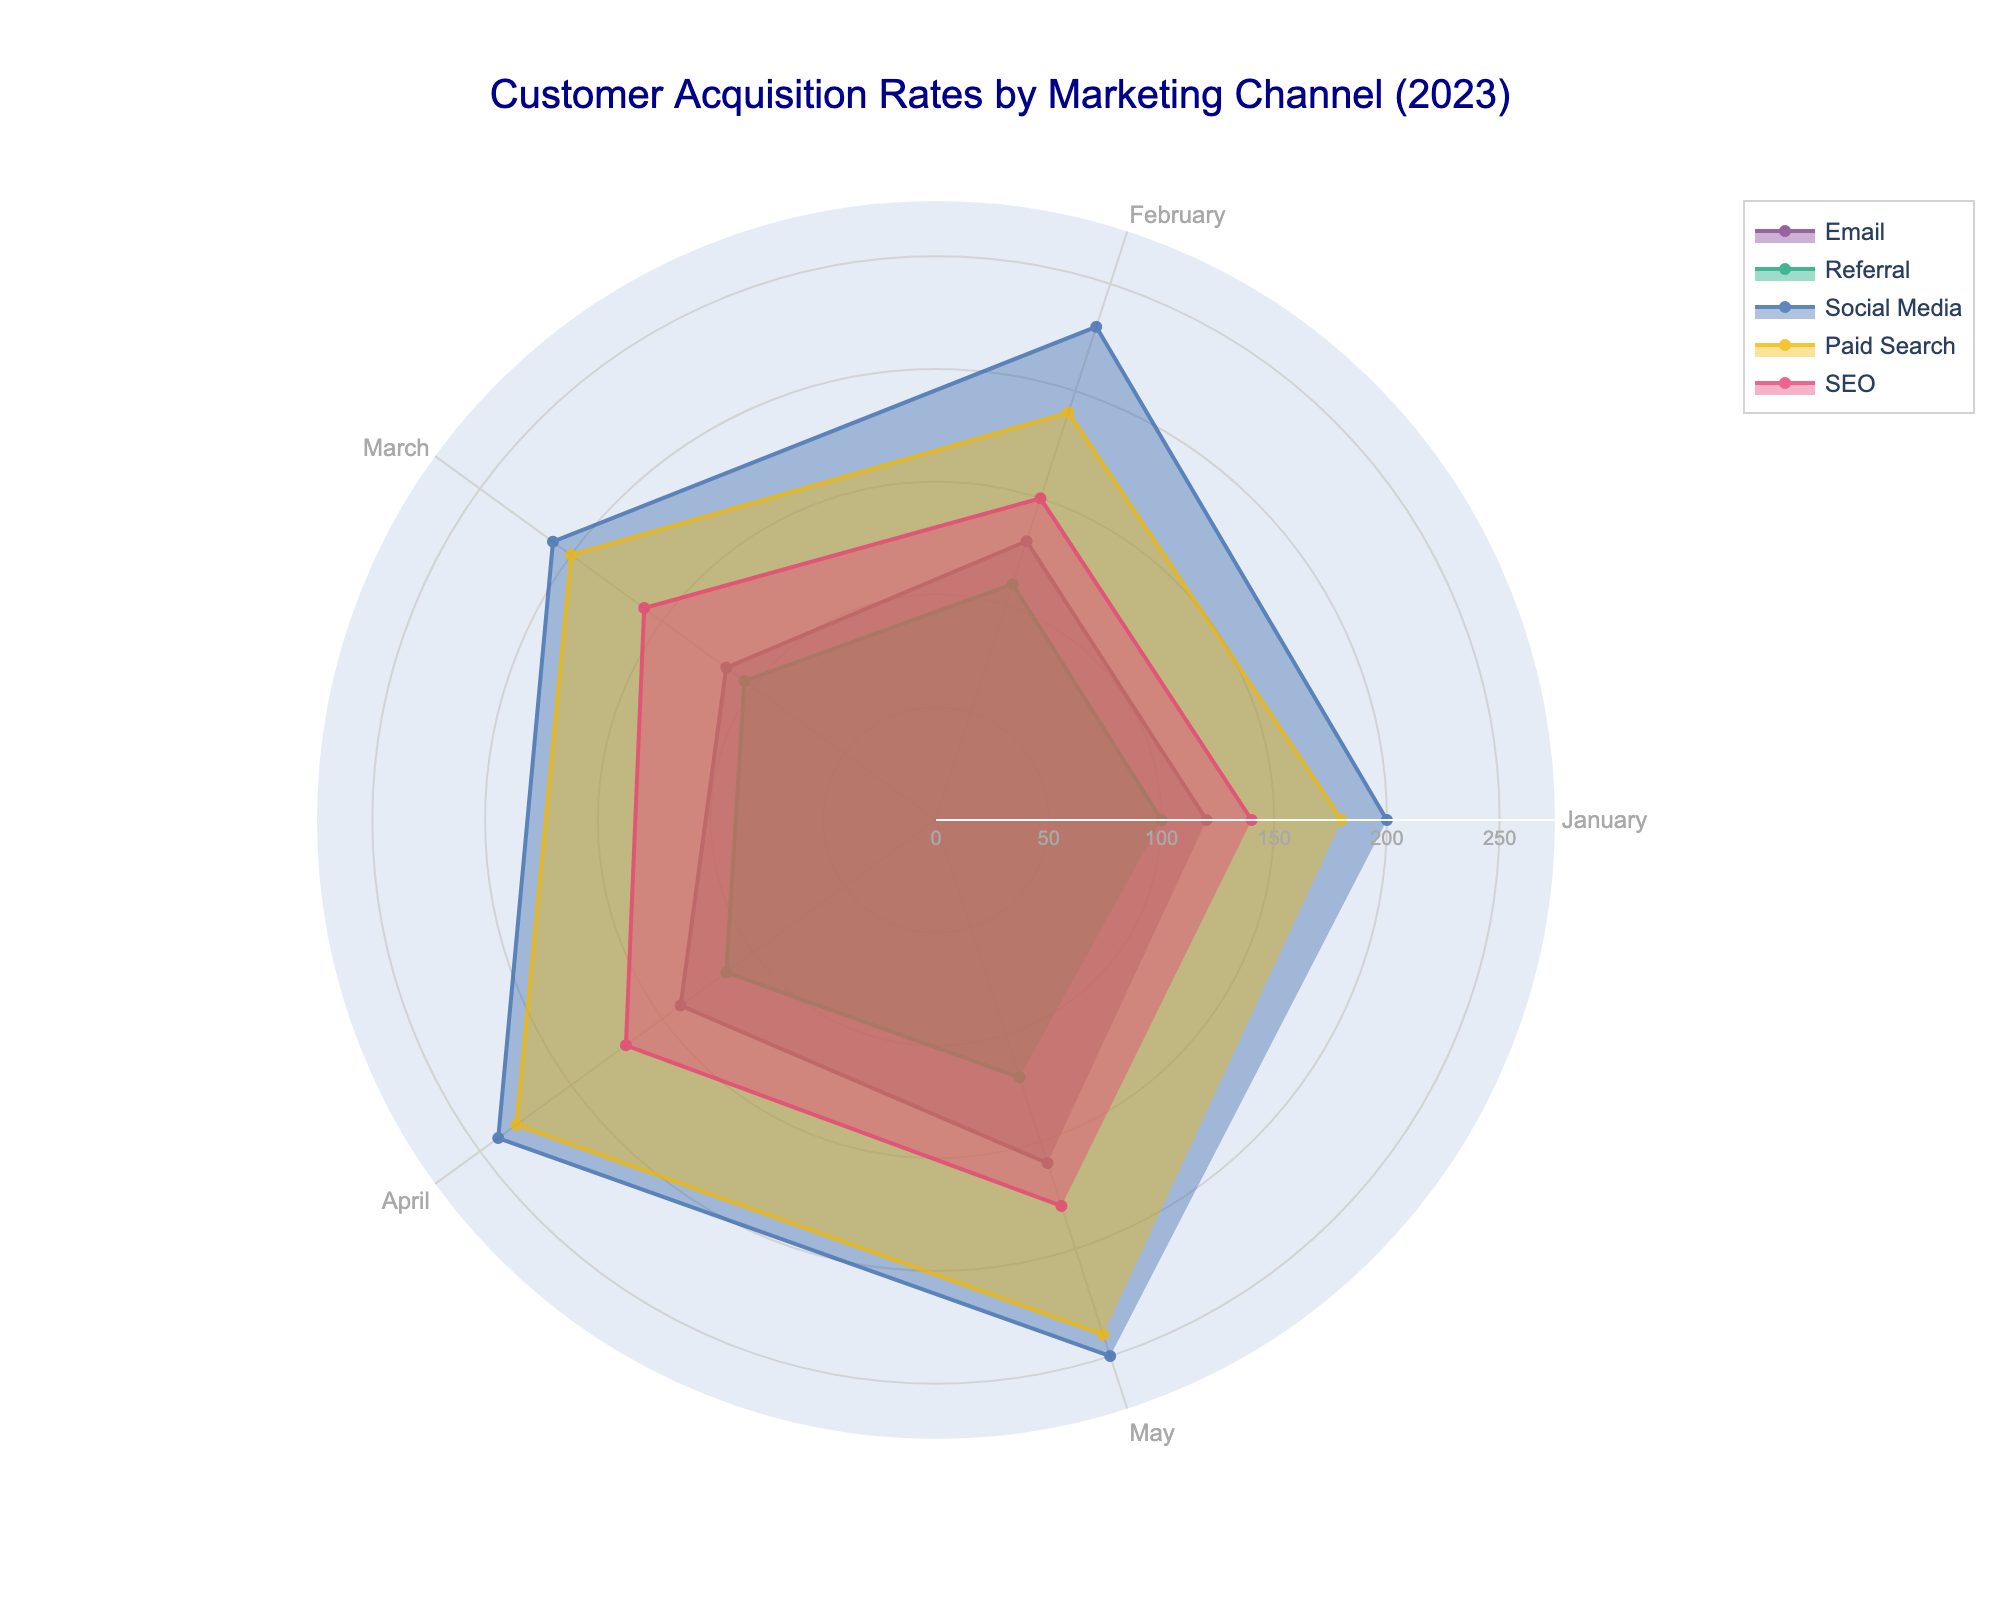What is the title of the figure? The title is usually displayed at the top center of the figure. For this plot, it clearly states: "Customer Acquisition Rates by Marketing Channel (2023)"
Answer: Customer Acquisition Rates by Marketing Channel (2023) Which marketing channel had the highest customer acquisition rate in May 2023? By looking at the outermost points in May for each channel on the polar chart (specifically the "May" section), Social Media has the highest value
Answer: Social Media During which month did the Email channel have the highest customer acquisition rate? Find the peak value of the Email channel marked with the specific color across the months. Observing the extends of the segments, May shows the highest value for Email
Answer: May Compare the customer acquisition rates of SEO and Paid Search in March 2023. Which one is higher? Check the radial lengths for SEO and Paid Search in the March segment of the polar chart, Paid Search shows a longer length compared to SEO
Answer: Paid Search What is the average customer acquisition rate for the Social Media channel from January to May 2023? Add the monthly rates for Social Media (200 + 230 + 210 + 240 + 250) and divide by the number of months (5), resulting in \( \frac{200+230+210+240+250}{5} = 226 \)
Answer: 226 Which marketing channel shows the most significant growth in customer acquisition rates from January to May 2023? Observe the trend of radial lengths over time. The Social Media channel shows a consistent and substantial increase from January to May, judging by the larger expanding area
Answer: Social Media What was the customer acquisition rate for Referral channel in April 2023? Look at the April section of the polar chart for the Referral color. The length reaches 115 units
Answer: 115 Which two channels had the smallest difference in their customer acquisition rates in January 2023? Compare the radial lengths for January. The smallest difference is between Referral (100) and Email (120), giving a difference of 20 units
Answer: Referral and Email Between SEO and Email, which channel displayed a more consistent trend in customer acquisition rates over the months? Consistency can be judged by less fluctuation. The SEO channel shows a smoother trend line, whereas Email has more variability in its lengths between months
Answer: SEO How does the customer acquisition trend for Paid Search compare to Referral from January to May 2023? Paid Search shows a significant increase over months, starting from a higher baseline (180 to 240), while Referral increases minimally (100 to 120), indicating Paid Search grows faster and covers more area
Answer: Paid Search grows faster 